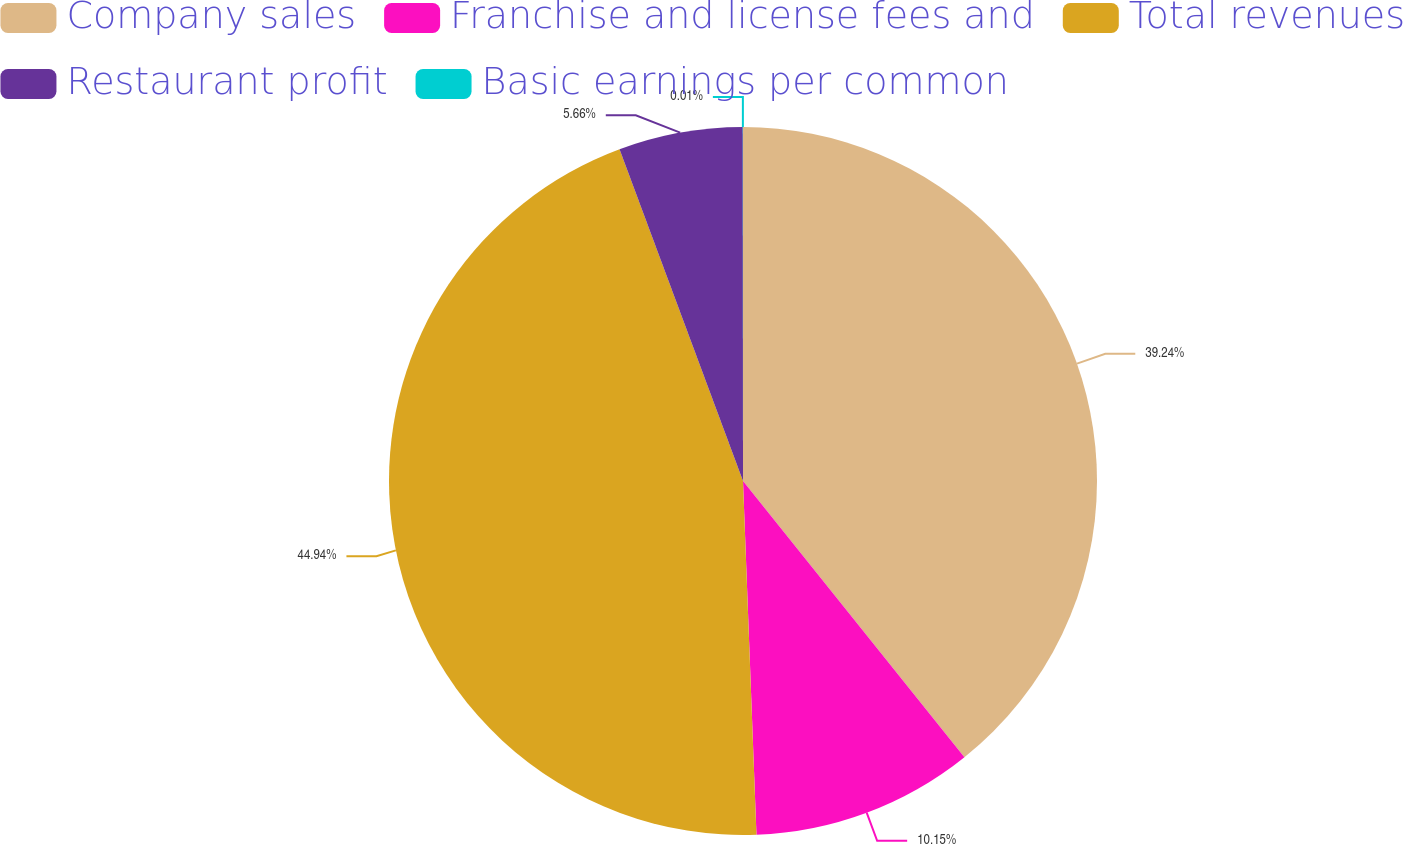Convert chart. <chart><loc_0><loc_0><loc_500><loc_500><pie_chart><fcel>Company sales<fcel>Franchise and license fees and<fcel>Total revenues<fcel>Restaurant profit<fcel>Basic earnings per common<nl><fcel>39.24%<fcel>10.15%<fcel>44.93%<fcel>5.66%<fcel>0.01%<nl></chart> 